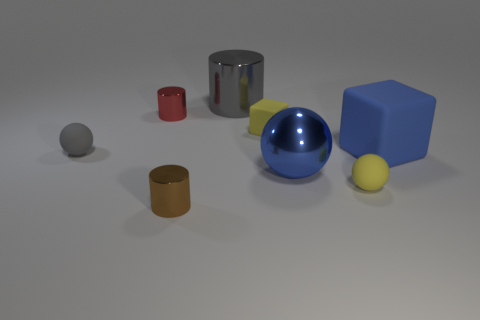Are there more tiny red cylinders that are in front of the big blue shiny thing than cylinders behind the large rubber thing?
Provide a short and direct response. No. The gray ball is what size?
Offer a terse response. Small. There is a tiny matte object on the left side of the tiny red shiny cylinder; what is its shape?
Your response must be concise. Sphere. Is the shape of the red object the same as the big blue rubber thing?
Your answer should be very brief. No. Are there the same number of gray metallic cylinders left of the gray cylinder and matte balls?
Give a very brief answer. No. What shape is the small gray rubber object?
Provide a short and direct response. Sphere. Is there any other thing that is the same color as the large ball?
Provide a short and direct response. Yes. There is a sphere to the left of the gray metallic cylinder; does it have the same size as the blue thing that is in front of the tiny gray thing?
Provide a succinct answer. No. The yellow matte thing right of the large shiny object that is in front of the gray matte thing is what shape?
Offer a terse response. Sphere. There is a brown cylinder; is its size the same as the blue object behind the tiny gray rubber sphere?
Give a very brief answer. No. 